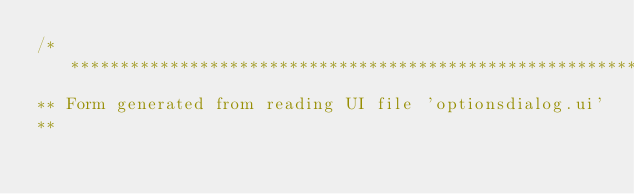Convert code to text. <code><loc_0><loc_0><loc_500><loc_500><_C_>/********************************************************************************
** Form generated from reading UI file 'optionsdialog.ui'
**</code> 